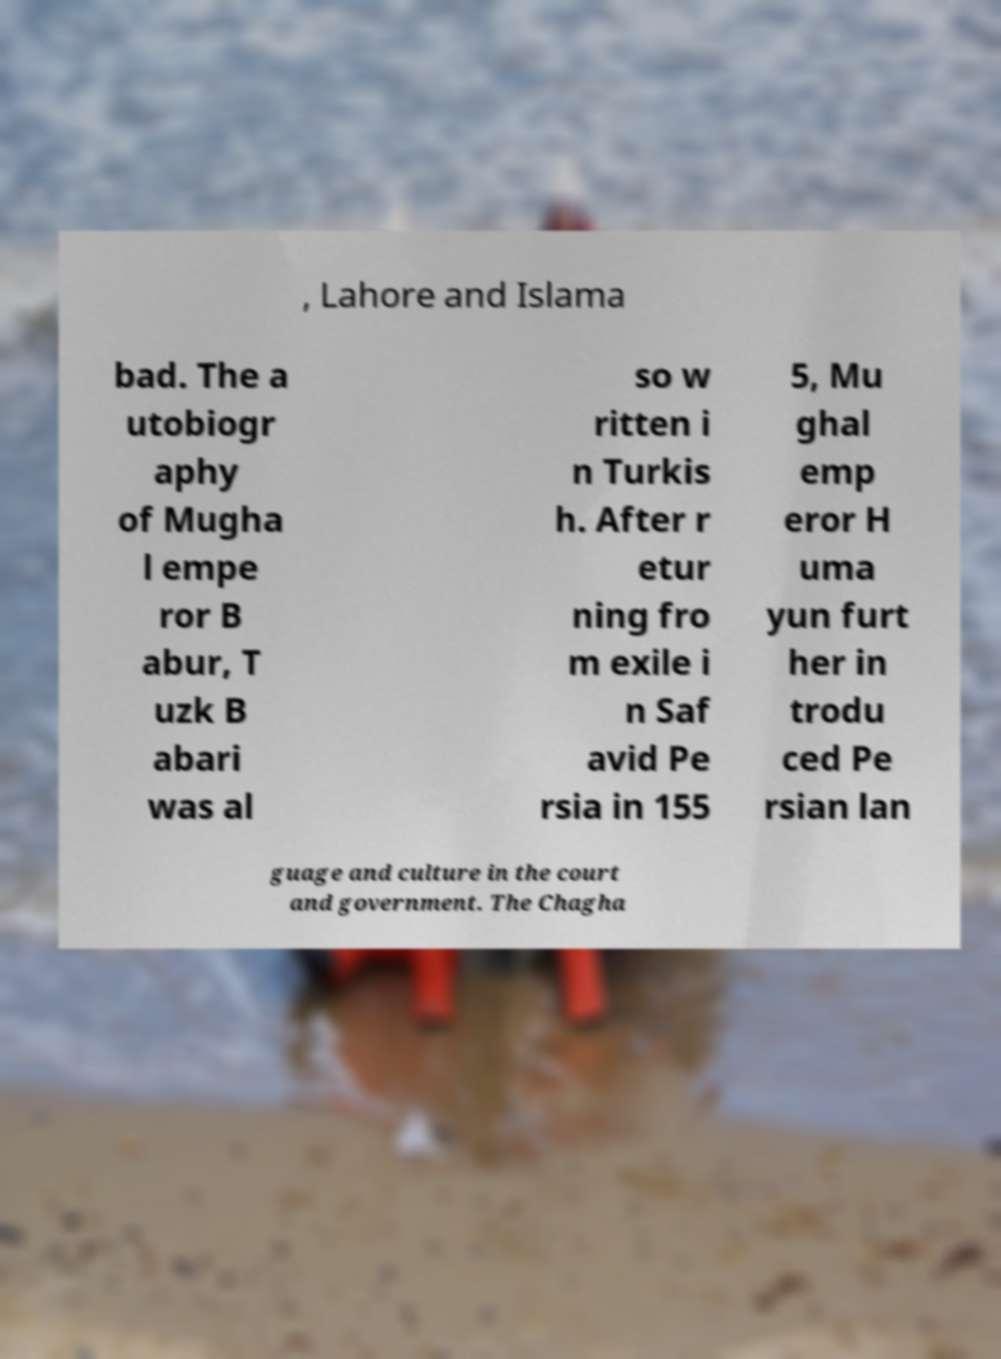Can you accurately transcribe the text from the provided image for me? , Lahore and Islama bad. The a utobiogr aphy of Mugha l empe ror B abur, T uzk B abari was al so w ritten i n Turkis h. After r etur ning fro m exile i n Saf avid Pe rsia in 155 5, Mu ghal emp eror H uma yun furt her in trodu ced Pe rsian lan guage and culture in the court and government. The Chagha 